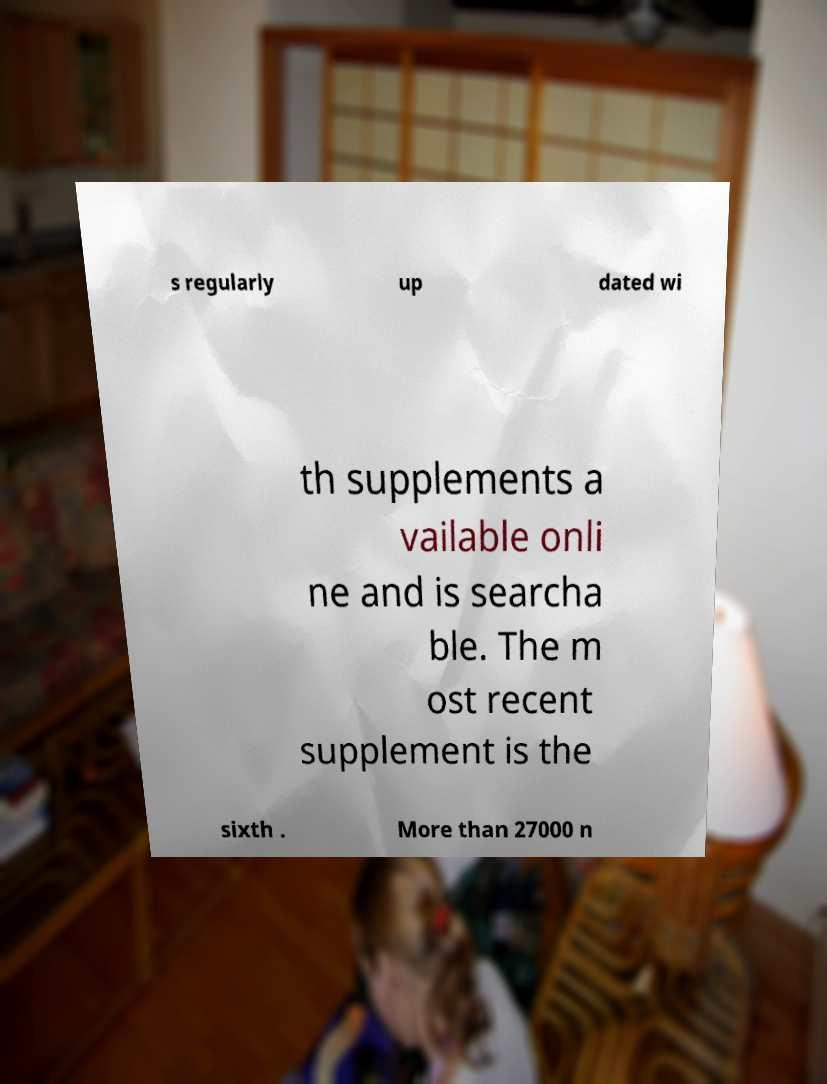I need the written content from this picture converted into text. Can you do that? s regularly up dated wi th supplements a vailable onli ne and is searcha ble. The m ost recent supplement is the sixth . More than 27000 n 